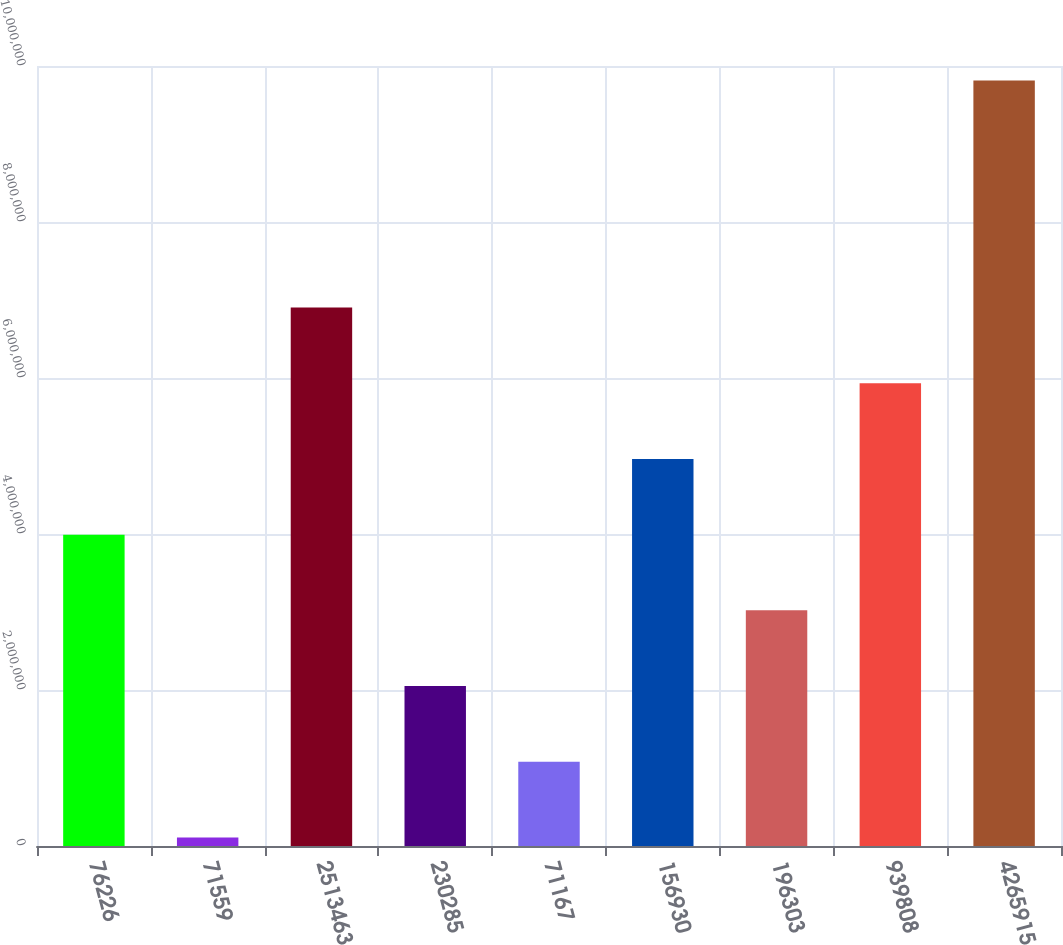<chart> <loc_0><loc_0><loc_500><loc_500><bar_chart><fcel>76226<fcel>71559<fcel>2513463<fcel>230285<fcel>71167<fcel>156930<fcel>196303<fcel>939808<fcel>4265915<nl><fcel>3.99174e+06<fcel>109664<fcel>6.90329e+06<fcel>2.0507e+06<fcel>1.08018e+06<fcel>4.96226e+06<fcel>3.02122e+06<fcel>5.93278e+06<fcel>9.81485e+06<nl></chart> 